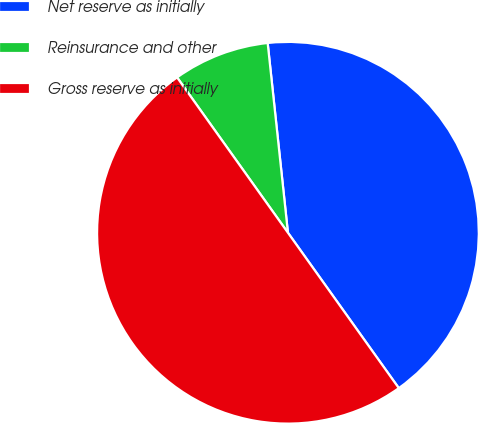Convert chart to OTSL. <chart><loc_0><loc_0><loc_500><loc_500><pie_chart><fcel>Net reserve as initially<fcel>Reinsurance and other<fcel>Gross reserve as initially<nl><fcel>41.83%<fcel>8.17%<fcel>50.0%<nl></chart> 